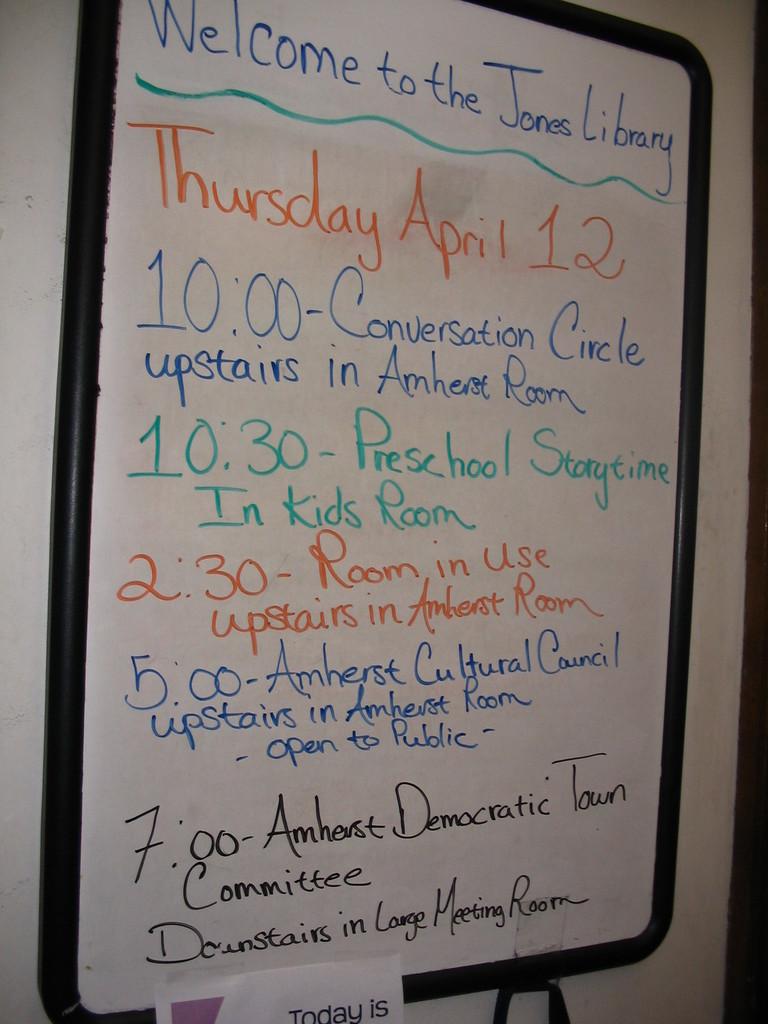When does story time start?
Your answer should be compact. 10:30. What day is mentioned at the top?
Offer a terse response. Thursday. 